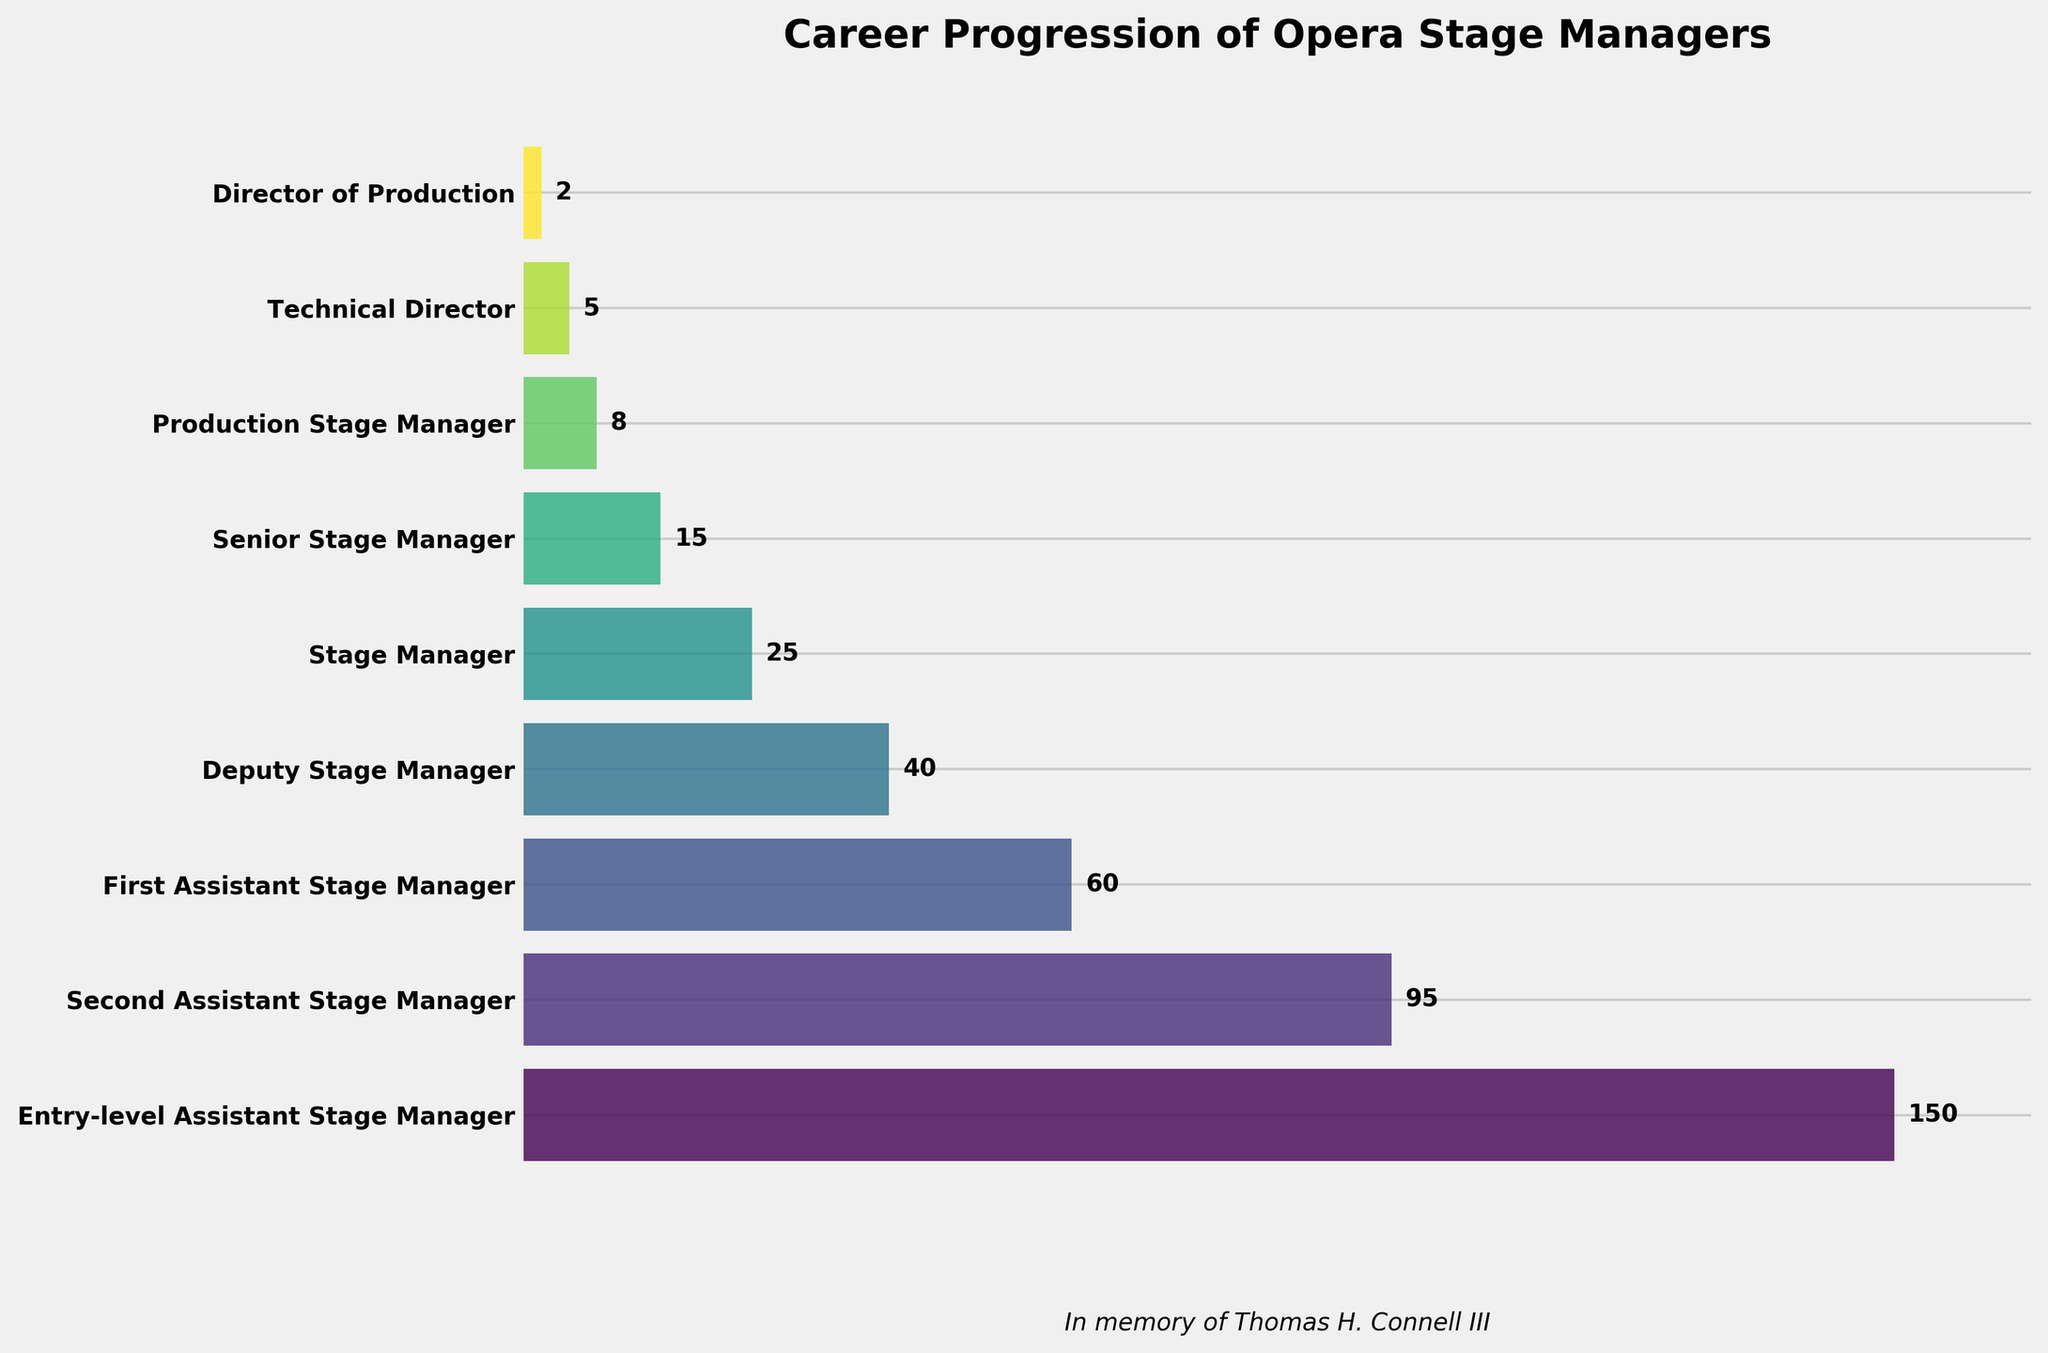What is the title of the figure? The title is usually placed at the top of the figure and in this case is in bold font.
Answer: Career Progression of Opera Stage Managers Which stage has the highest number of professionals? The first category on the funnel chart typically represents the group with the highest number since the funnel narrows as it progresses.
Answer: Entry-level Assistant Stage Manager What is the number of professionals in the position of Technical Director? The figure shows the number of professionals in each stage beside the bars.
Answer: 5 How many stages are displayed in the funnel chart? By counting the individual bars or stages listed on the y-axis.
Answer: 9 What percentage of professionals hold the title of Production Stage Manager compared to Entry-level Assistant Stage Manager? Production Stage Manager has 8 professionals, and Entry-level Assistant Stage Manager has 150 professionals. Calculating the percentage: (8 / 150) * 100.
Answer: Approximately 5.33% What is the difference in the number of professionals between Deputy Stage Manager and Stage Manager? Locate the number of professionals for both stages and subtract the smaller from the larger: 40 (Deputy) - 25 (Stage).
Answer: 15 How does the number of professionals in the Senior Stage Manager position compare to those in the Director of Production position? Compare the numbers directly: 15 (Senior Stage Manager) > 2 (Director of Production).
Answer: There's a significantly larger number of Senior Stage Managers Which stage marks the halfway point in the number of professionals in the funnel chart? Identify the stage where the cumulative total above and below is as close as possible.
Answer: First Assistant Stage Manager Is the reduction in number of professionals between each subsequent stage consistent? Evaluating the differences between each stage reveals the numbers are not decreasing at a consistent rate.
Answer: No, the reduction rate varies How many professionals does the funnel chart indicate are in any stage higher than Stage Manager? Sum the number of professionals in stages above Stage Manager: 15 (Senior Stage Manager) + 8 (Production Stage Manager) + 5 (Technical Director) + 2 (Director of Production) = 30.
Answer: 30 